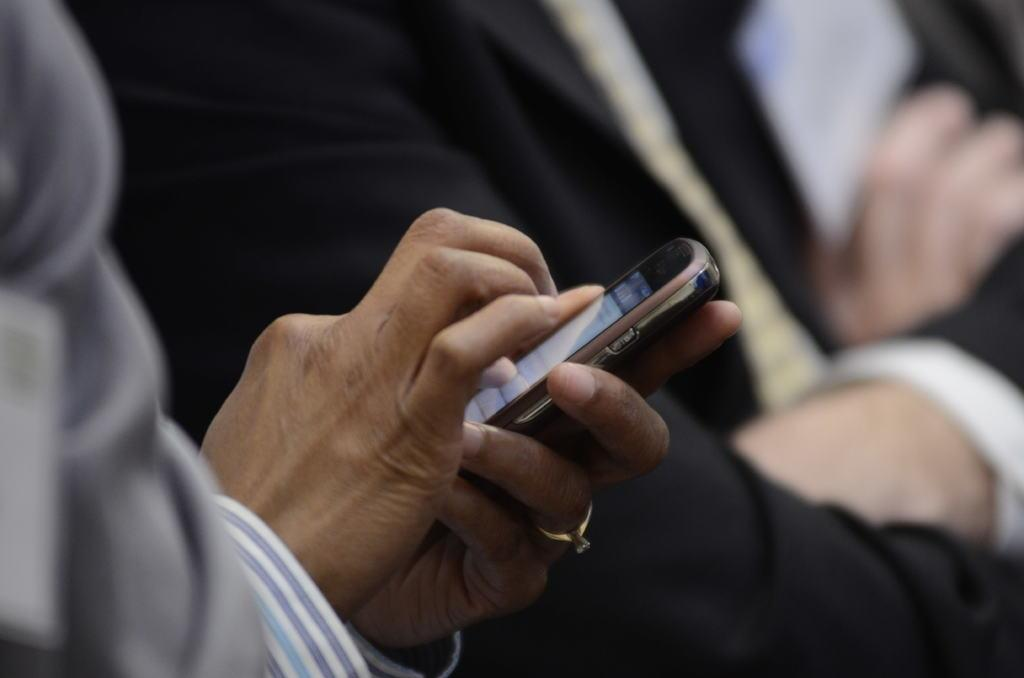What is the person's hand doing in the image? The hand is holding a mobile in the image. What accessory is the person wearing on their finger? The person is wearing a ring on their finger. Can you describe the person visible in the background of the image? The person in the background appears blurry. What type of pet can be seen in the nest in the image? There is no pet or nest present in the image. 